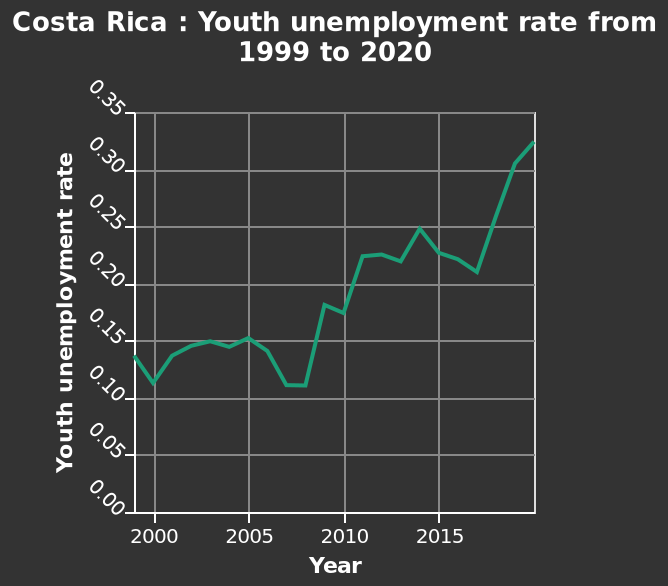<image>
Has the youth unemployment rate increased or decreased over the years?  The youth unemployment rate has increased over the years. 